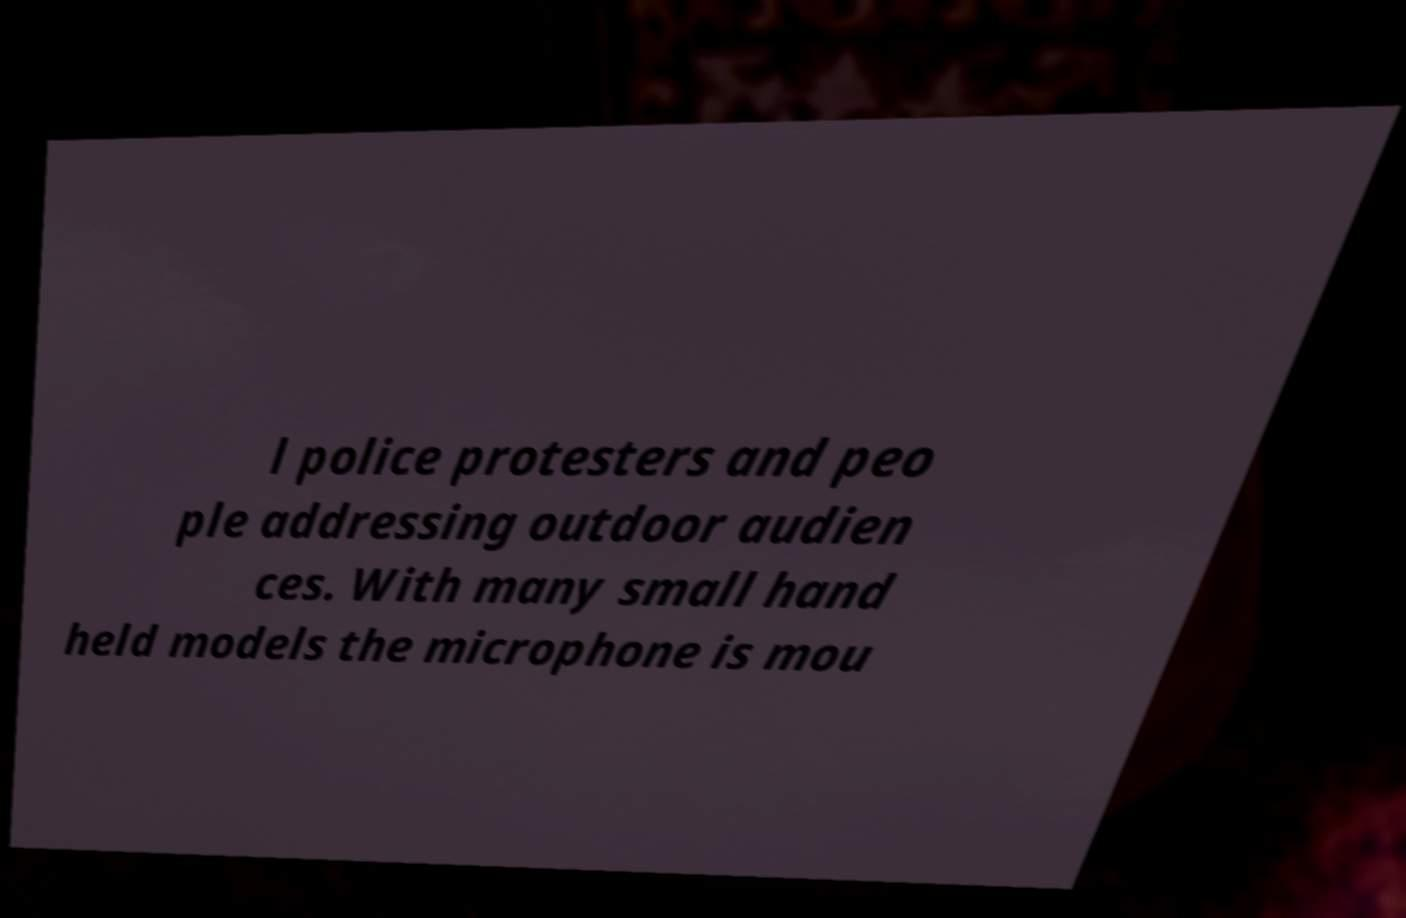For documentation purposes, I need the text within this image transcribed. Could you provide that? l police protesters and peo ple addressing outdoor audien ces. With many small hand held models the microphone is mou 